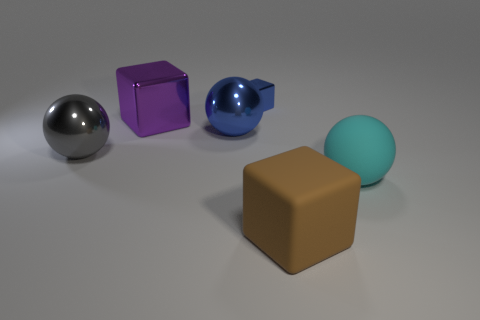What can we infer about the texture of the objects Based on the image, we can infer that the textures of the objects vary: the gray sphere looks metallic with a reflective surface, the purple cube seems slightly less reflective which could imply a satin finish, the blue sphere has a soft sheen suggesting it might be ceramic or enameled, and the brown cube appears completely matte, possibly indicative of a solid plastic or non-reflective material. 